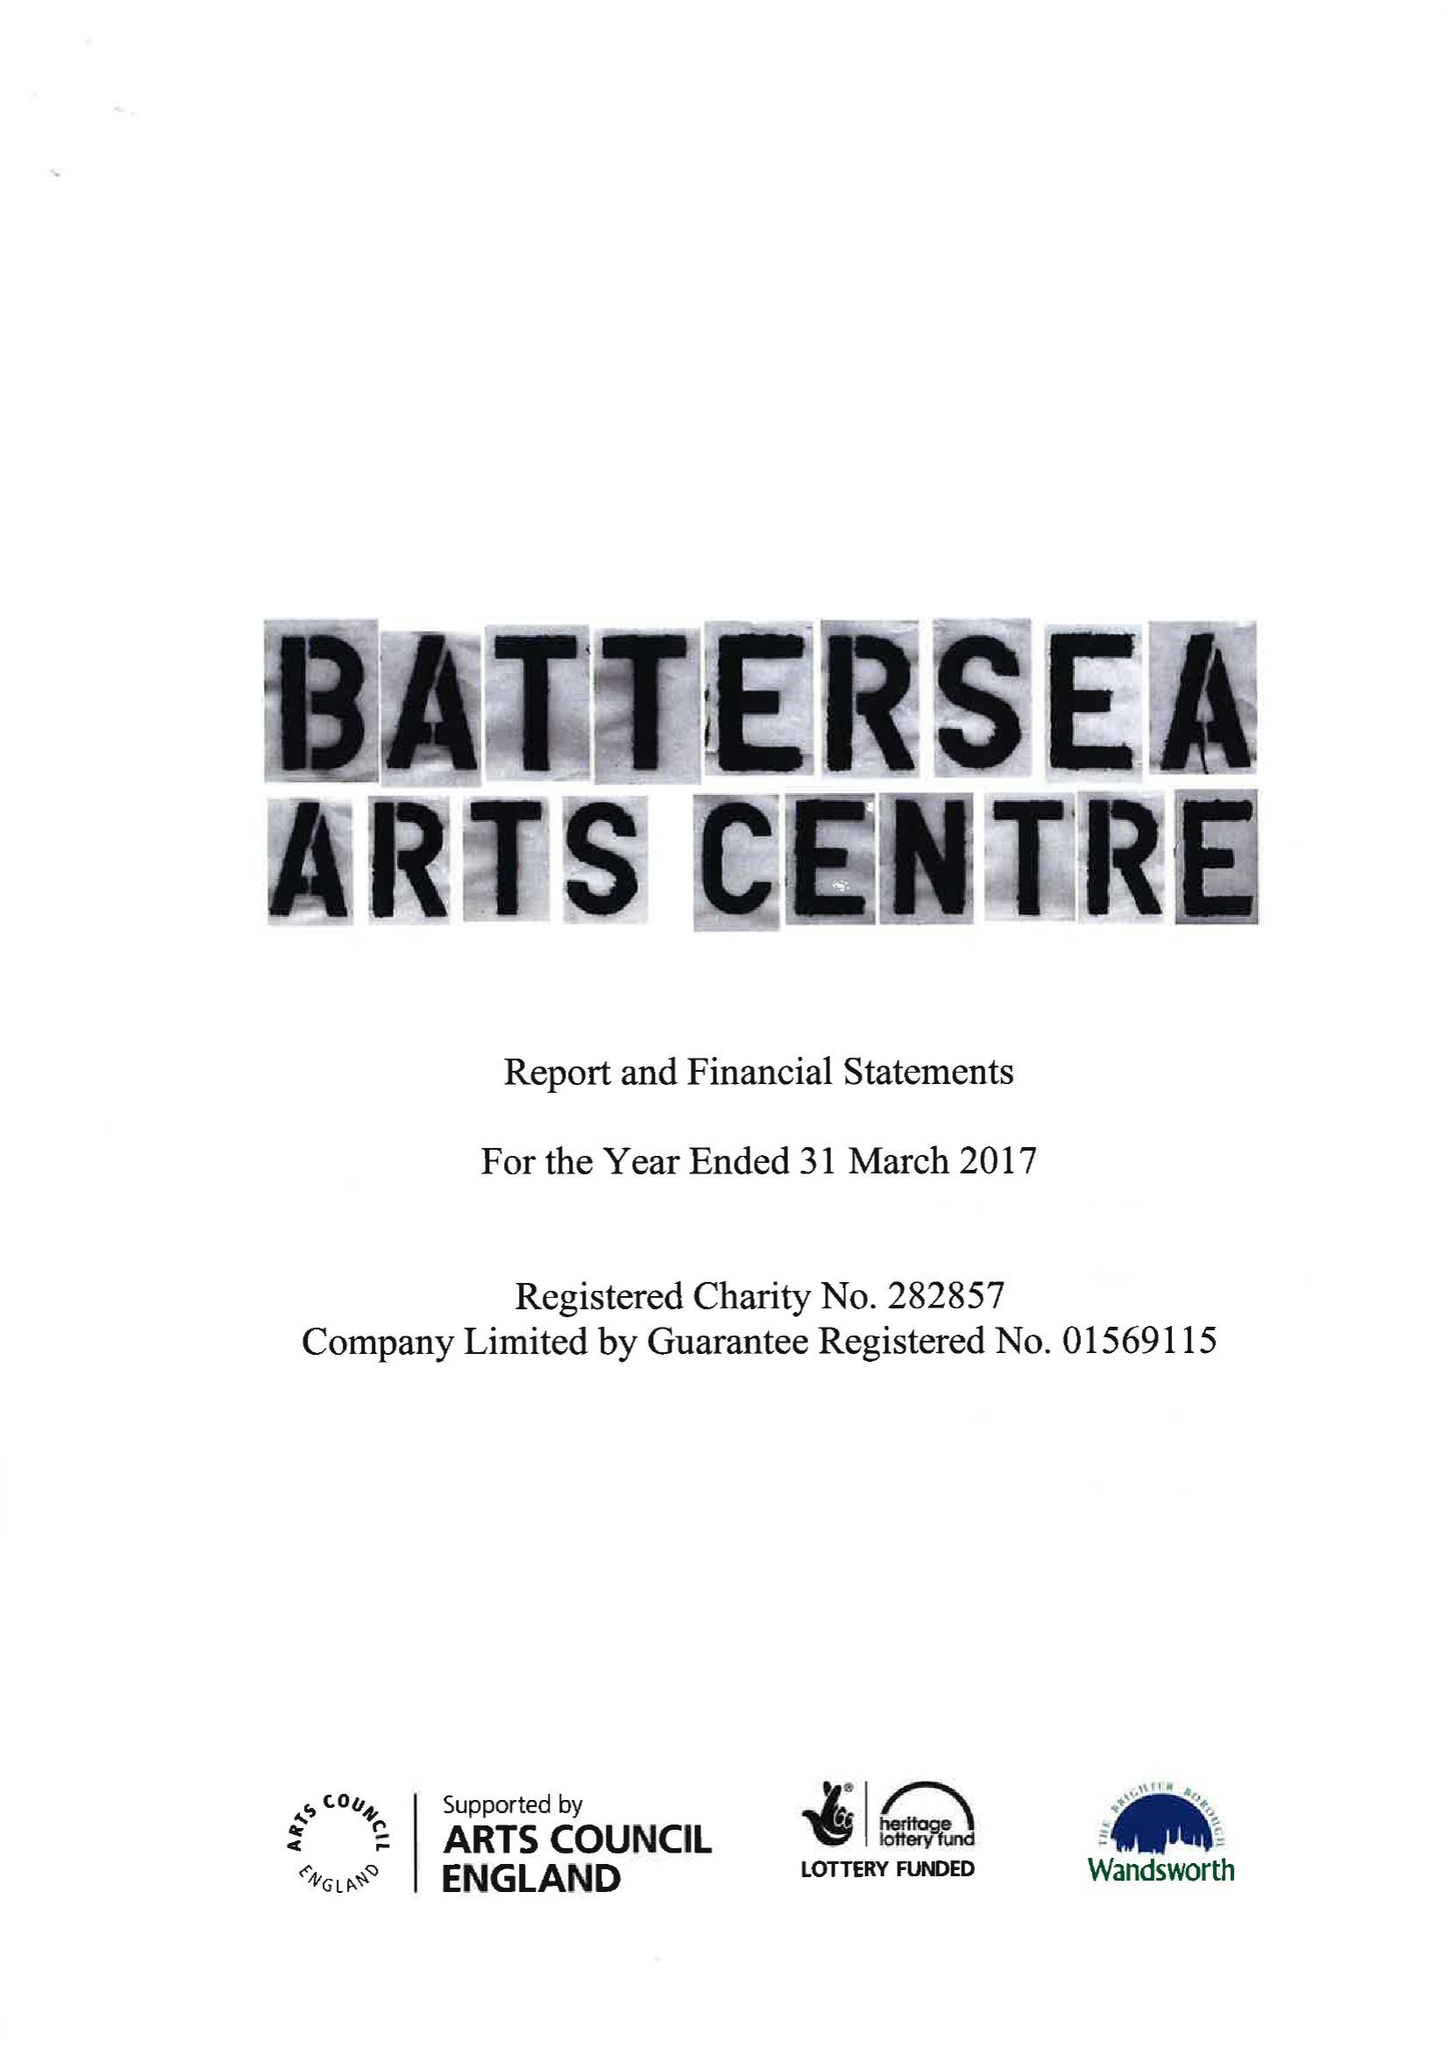What is the value for the income_annually_in_british_pounds?
Answer the question using a single word or phrase. 6448916.00 